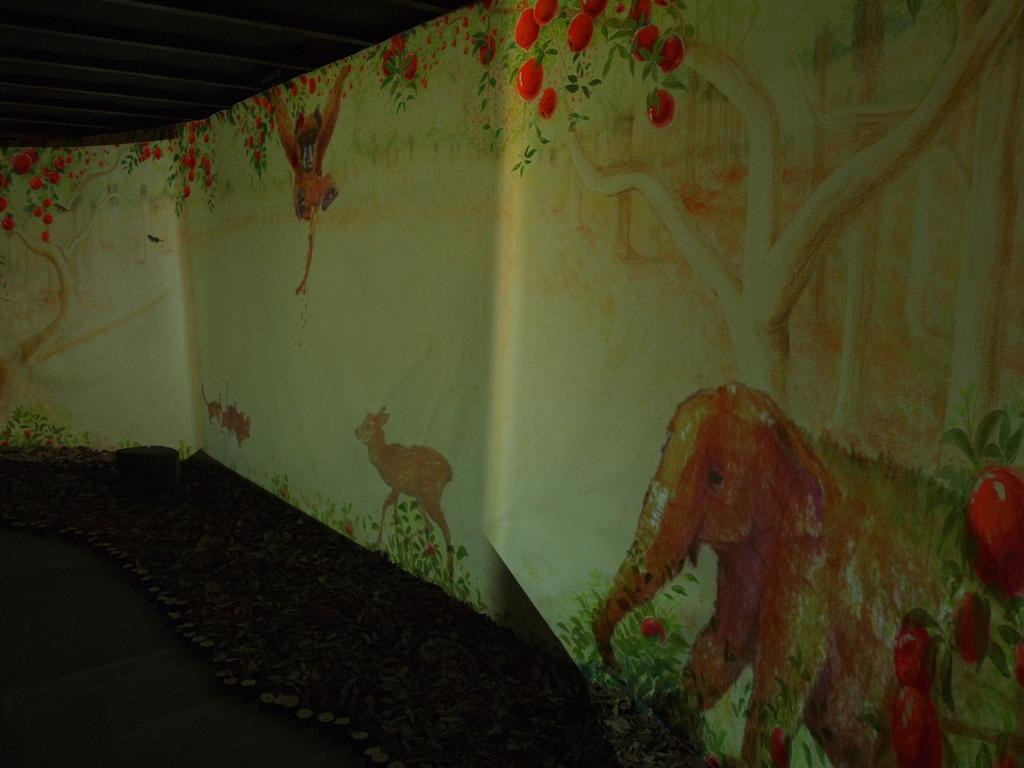Where was the image taken? The image was taken inside a room. What type of artwork is present on the walls in the image? There are paintings of trees and paintings of animals on the wall. What part of the room is visible in the image? The roof is visible in the image. What type of channel can be seen running through the room in the image? There is no channel visible in the image; it is taken inside a room with paintings on the walls and a visible roof. 